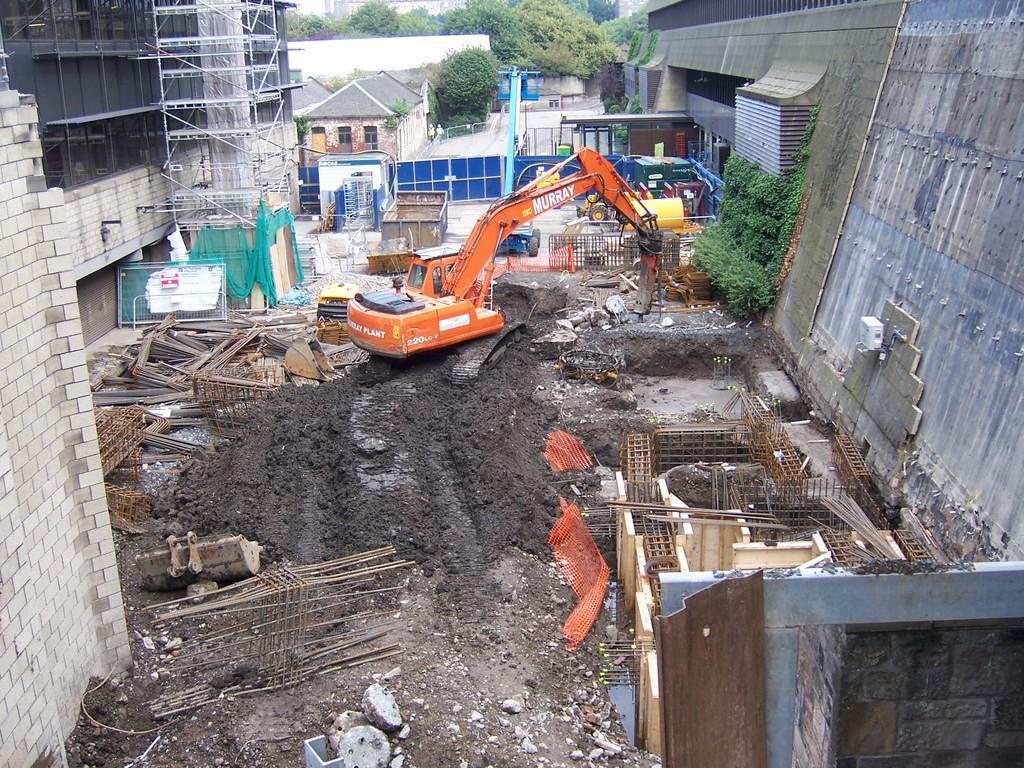Describe this image in one or two sentences. In this image I can observe a wall on the left side. In middle there is vehicle. On the right side there is a wall. In the background I can see some trees and houses. 